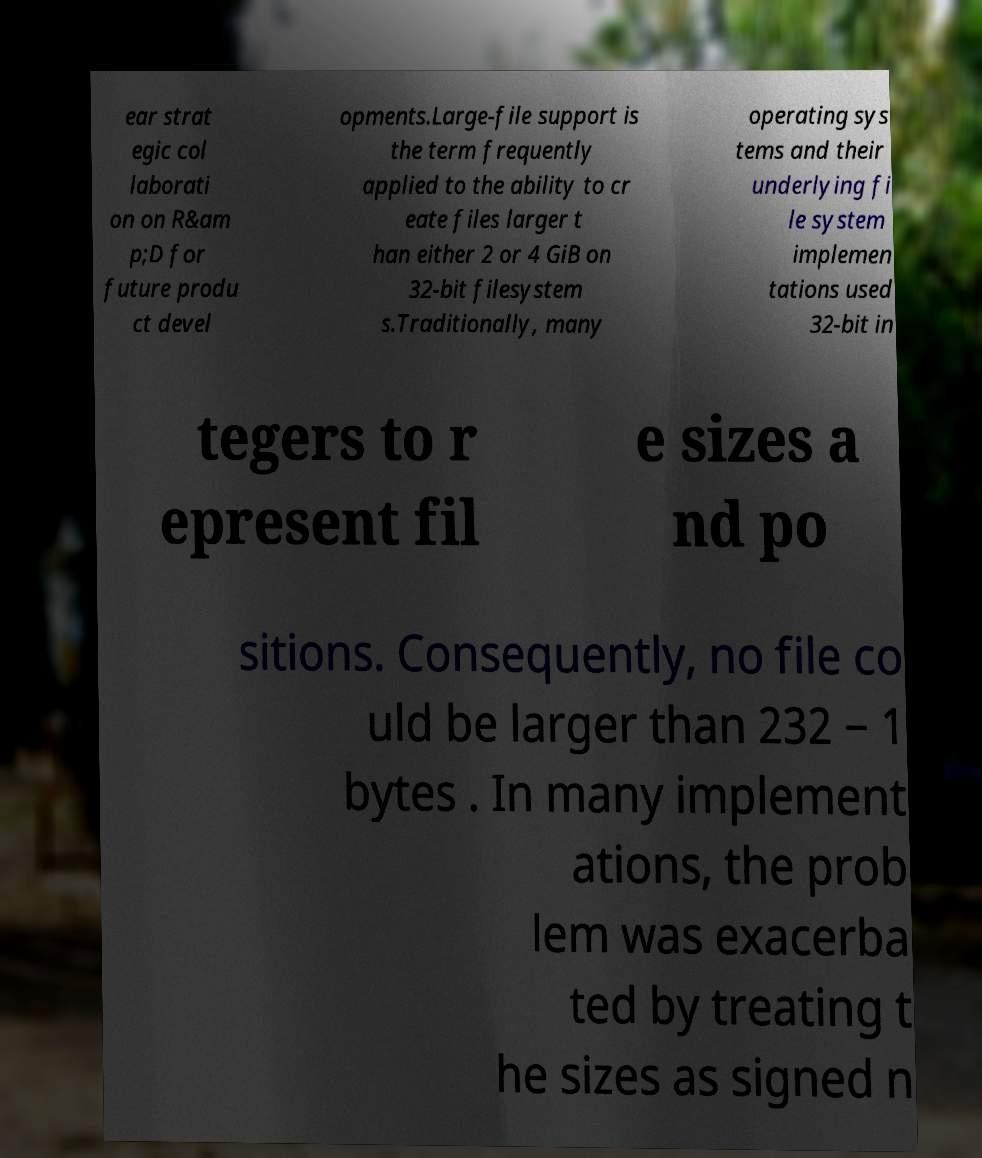Could you assist in decoding the text presented in this image and type it out clearly? ear strat egic col laborati on on R&am p;D for future produ ct devel opments.Large-file support is the term frequently applied to the ability to cr eate files larger t han either 2 or 4 GiB on 32-bit filesystem s.Traditionally, many operating sys tems and their underlying fi le system implemen tations used 32-bit in tegers to r epresent fil e sizes a nd po sitions. Consequently, no file co uld be larger than 232 − 1 bytes . In many implement ations, the prob lem was exacerba ted by treating t he sizes as signed n 